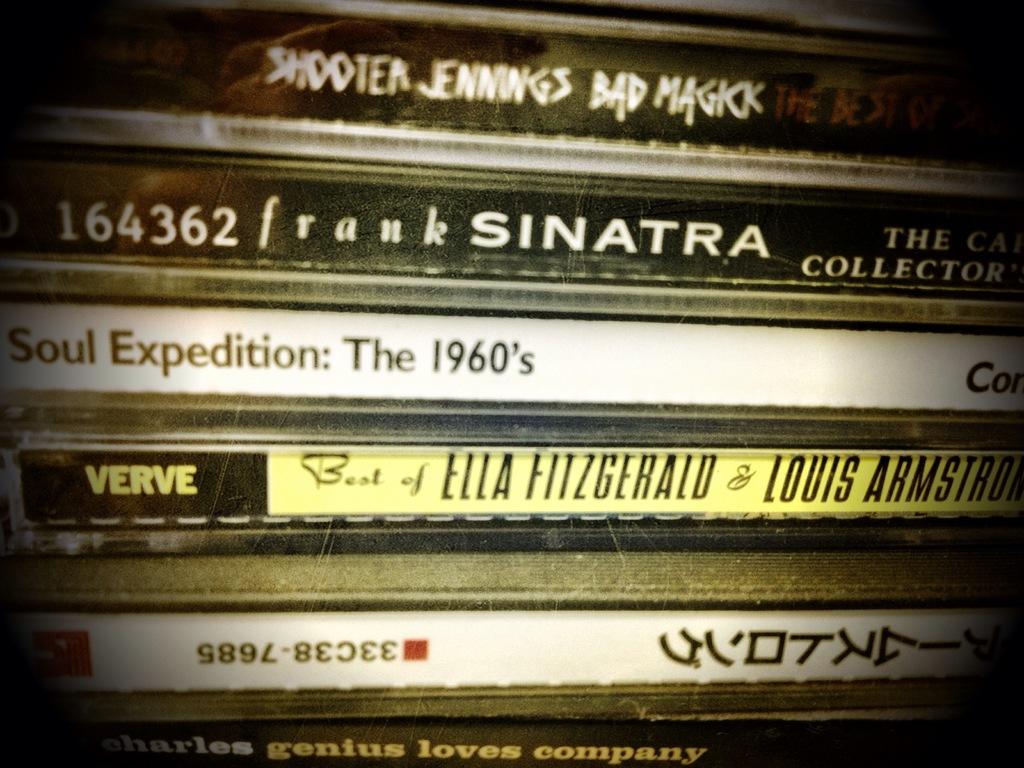What decade is on soul expedition?
Make the answer very short. 1960's. 